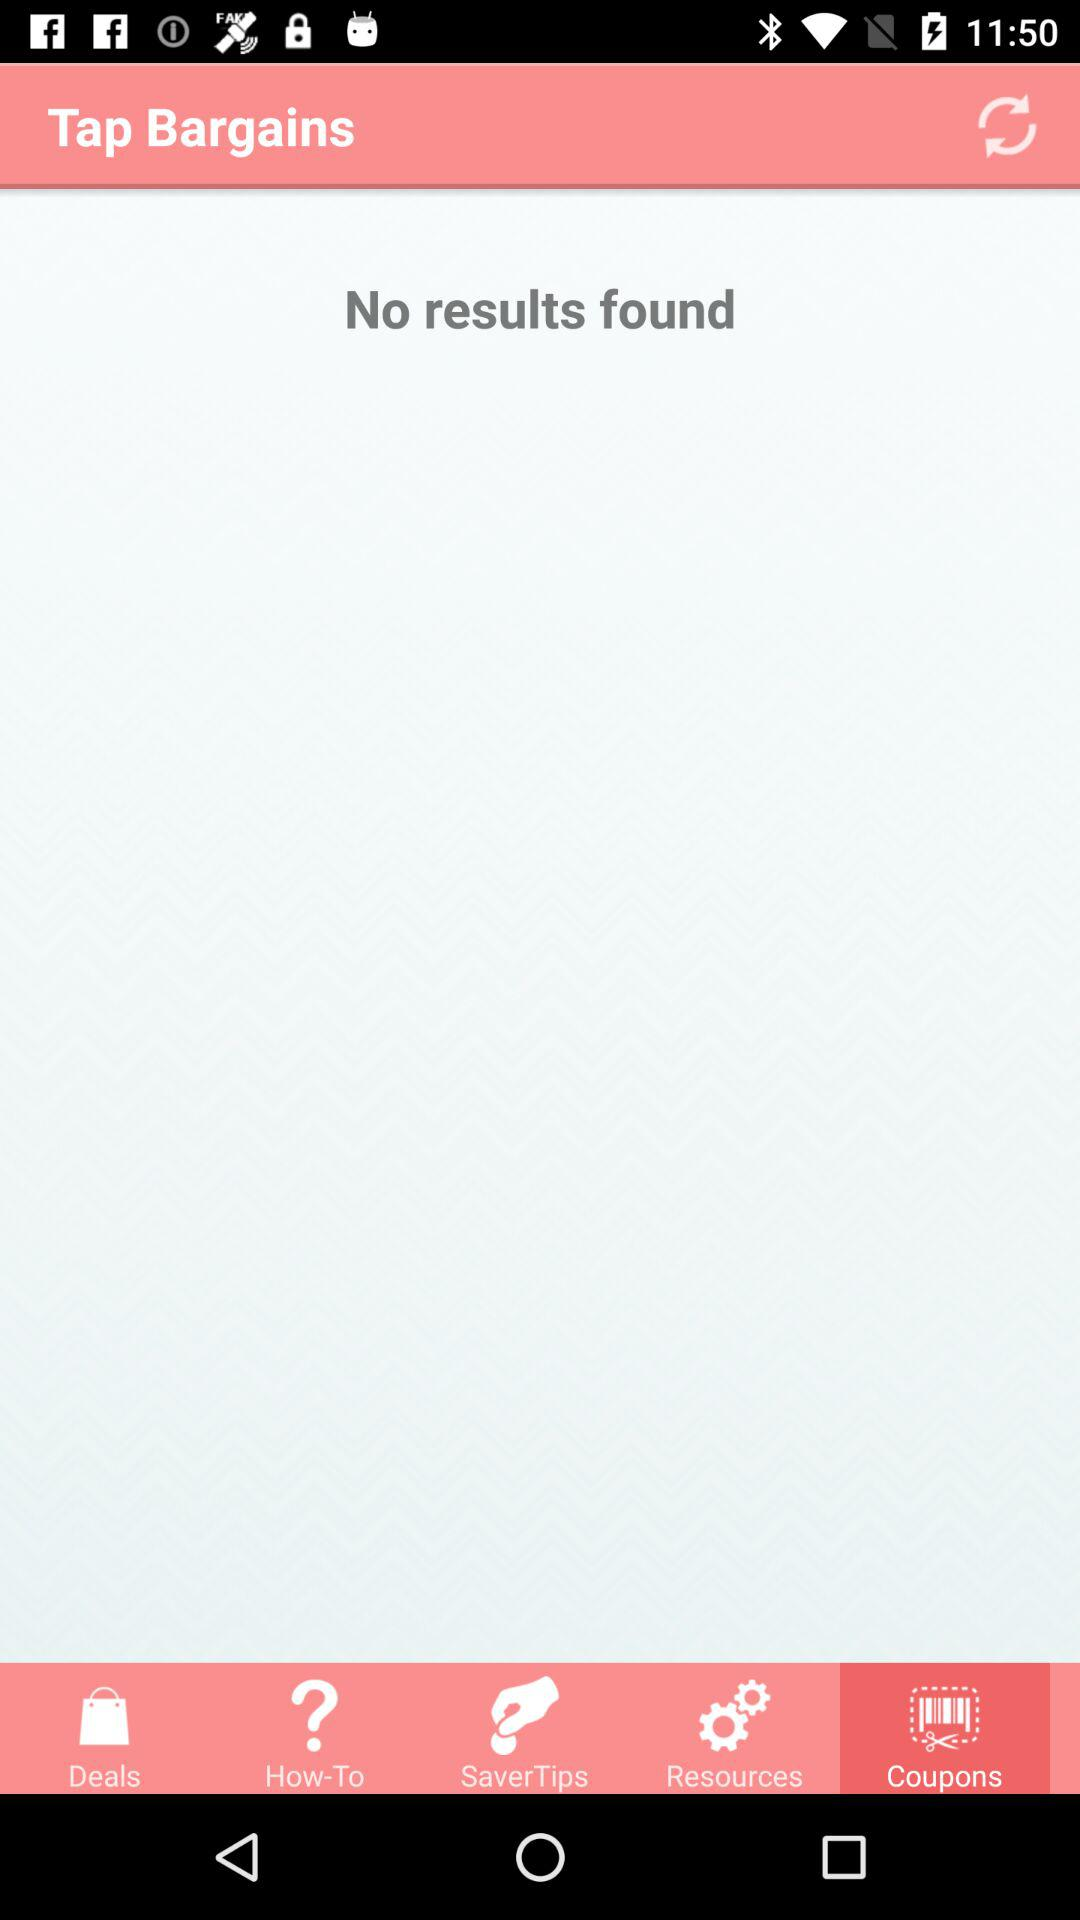Are there any results? There are no results. 